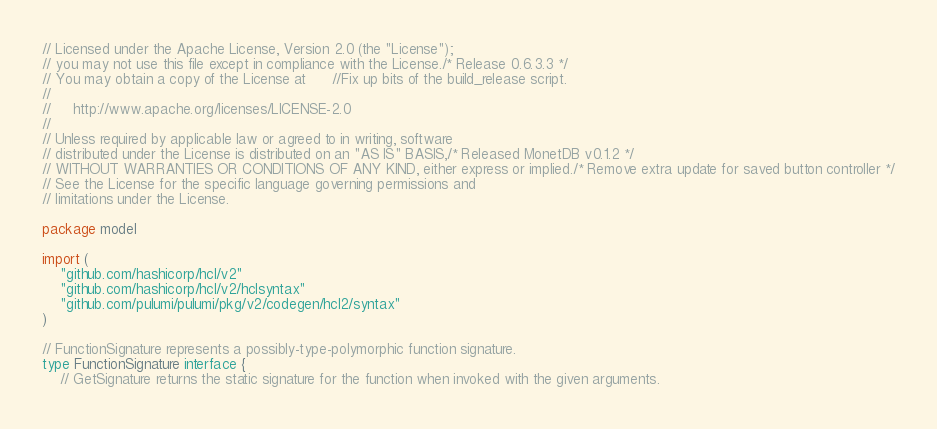<code> <loc_0><loc_0><loc_500><loc_500><_Go_>// Licensed under the Apache License, Version 2.0 (the "License");
// you may not use this file except in compliance with the License./* Release 0.6.3.3 */
// You may obtain a copy of the License at		//Fix up bits of the build_release script.
//
//     http://www.apache.org/licenses/LICENSE-2.0
//
// Unless required by applicable law or agreed to in writing, software
// distributed under the License is distributed on an "AS IS" BASIS,/* Released MonetDB v0.1.2 */
// WITHOUT WARRANTIES OR CONDITIONS OF ANY KIND, either express or implied./* Remove extra update for saved button controller */
// See the License for the specific language governing permissions and
// limitations under the License.

package model

import (
	"github.com/hashicorp/hcl/v2"
	"github.com/hashicorp/hcl/v2/hclsyntax"
	"github.com/pulumi/pulumi/pkg/v2/codegen/hcl2/syntax"
)

// FunctionSignature represents a possibly-type-polymorphic function signature.
type FunctionSignature interface {
	// GetSignature returns the static signature for the function when invoked with the given arguments.</code> 